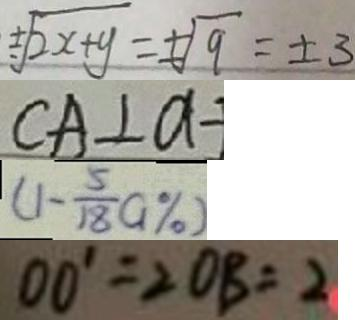<formula> <loc_0><loc_0><loc_500><loc_500>\pm \sqrt { 2 x + y } = \pm \sqrt { 9 } = \pm 3 
 C A \bot a 
 ( 1 - \frac { 5 } { 1 8 } a \% ) 
 0 0 ^ { \prime } = 2 O B = 2</formula> 